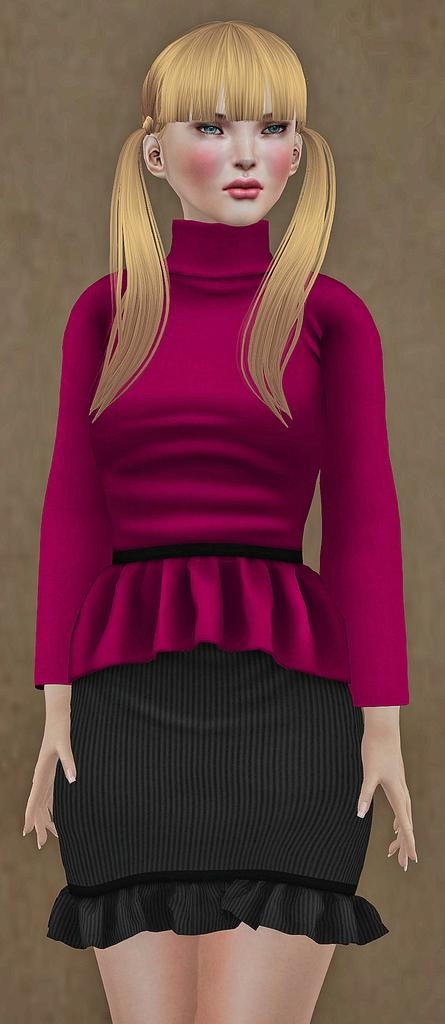What is the main subject of the image? The main subject of the image is a woman. What is the woman wearing on her upper body? The woman is wearing a pink long sleeve top. What is the woman wearing on her lower body? The woman is wearing a black skirt. What type of tank can be seen in the background of the image? There is no tank present in the image; it features a woman wearing a pink long sleeve top and a black skirt. What hobbies does the woman have, as depicted in the image? The image does not provide any information about the woman's hobbies. 